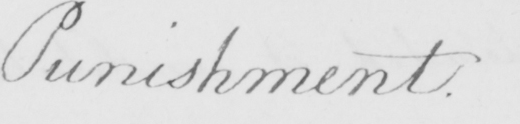Can you tell me what this handwritten text says? Punishment . 